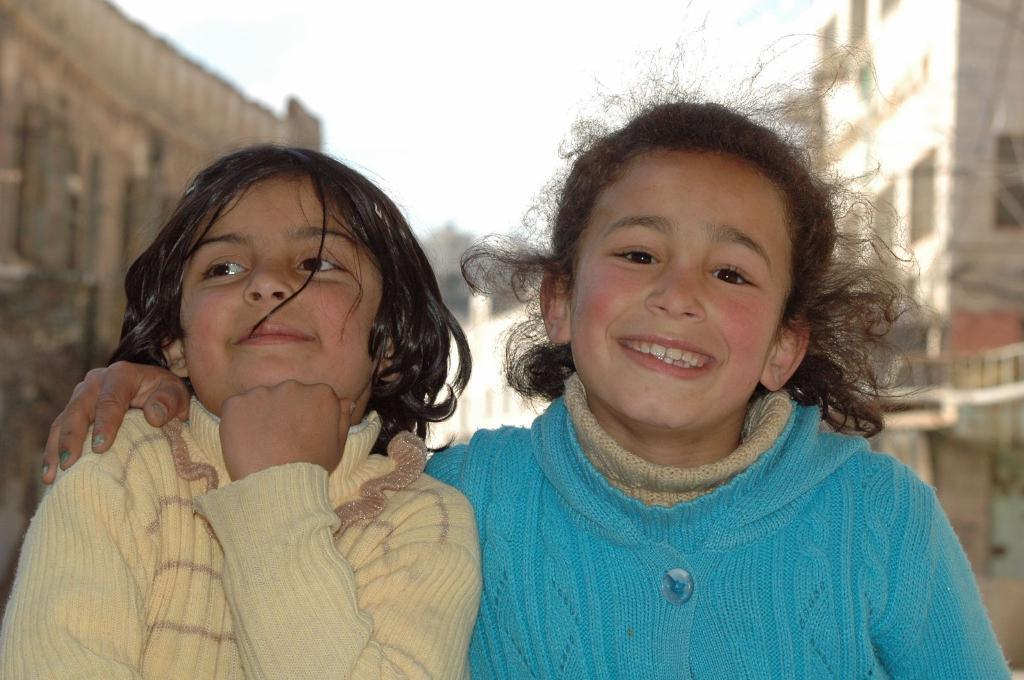How many people are in the image? There are two girls in the image. What is the facial expression of the girls? The girls are smiling. Can you describe the background of the image? The background of the image is blurry. What type of structures can be seen in the background? There are buildings visible in the background of the image. What type of disease is affecting the potato in the image? There is no potato present in the image, and therefore no disease can be observed. Can you tell me how many police officers are visible in the image? There are no police officers present in the image. 